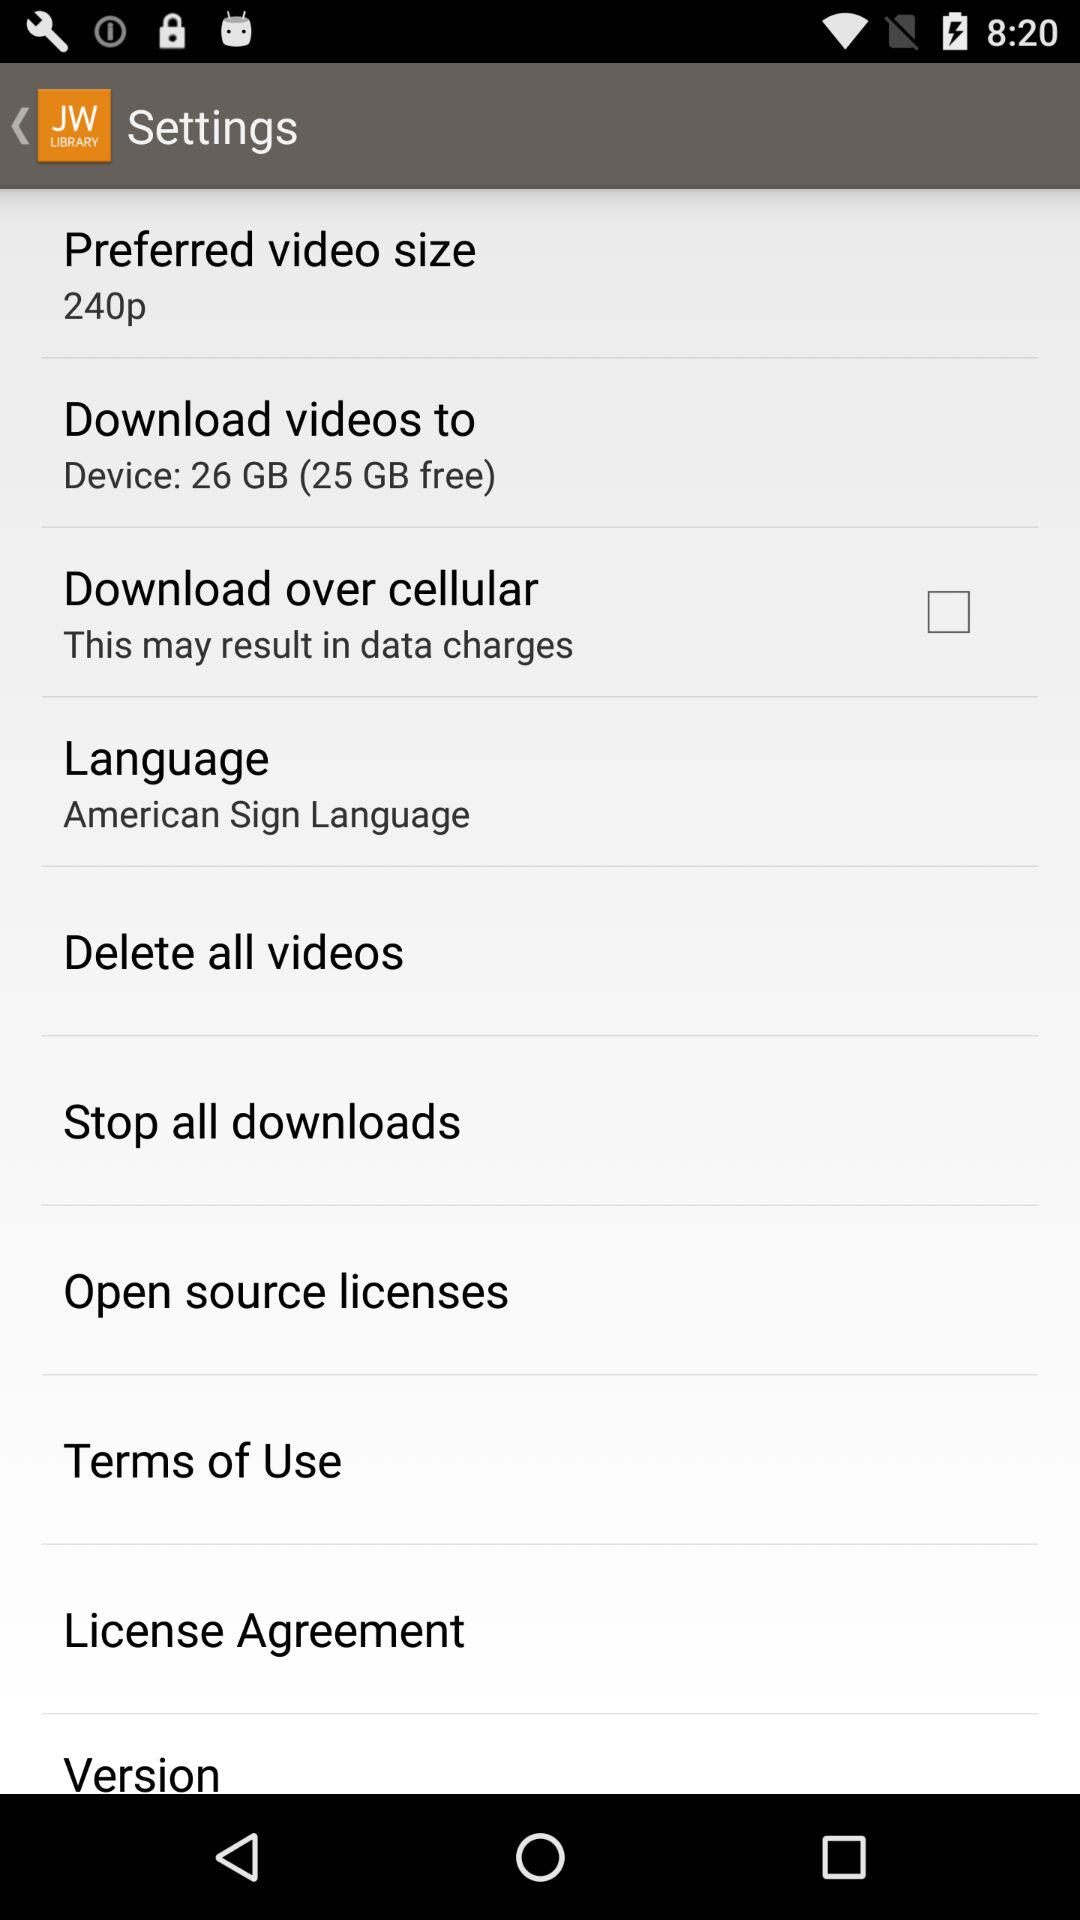How much space in GB is free on the device? The free space in GB on the device is 25. 